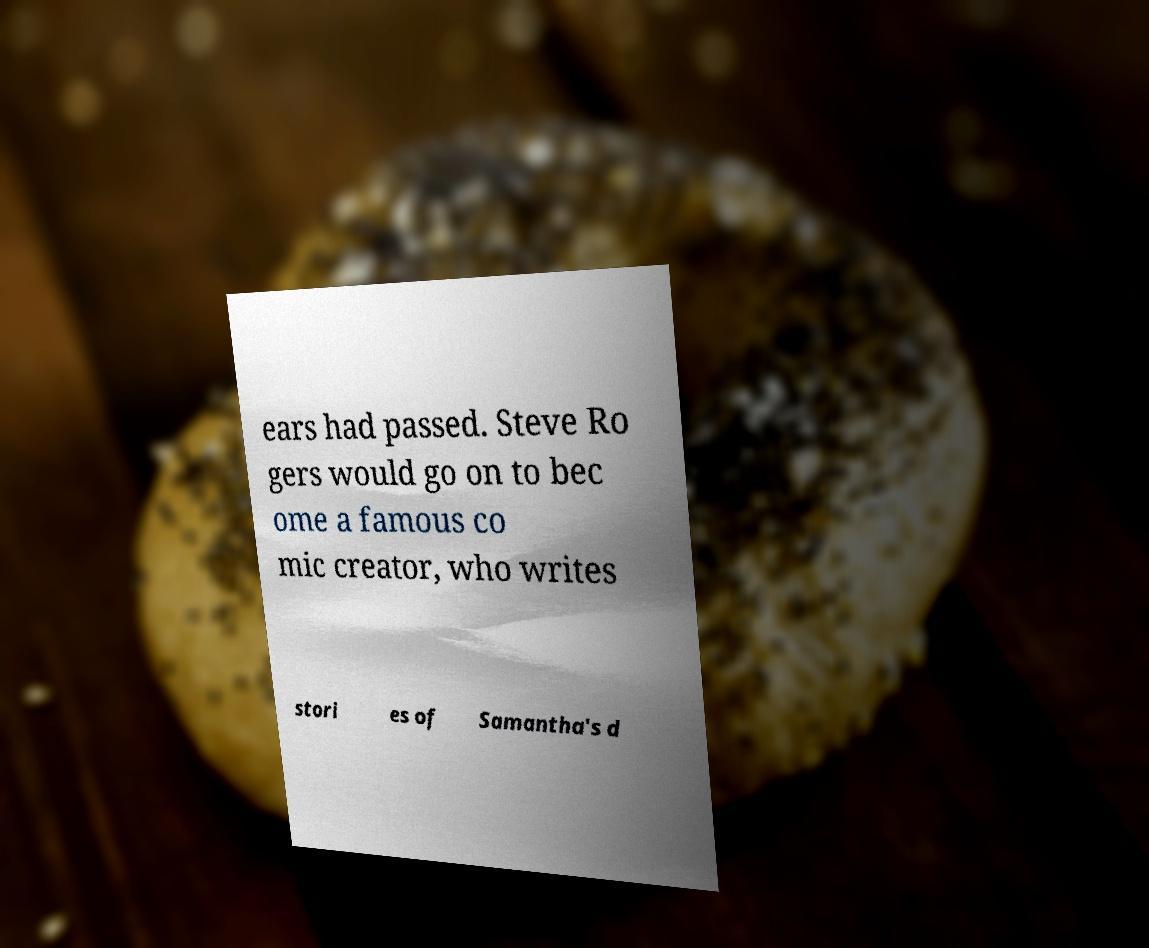There's text embedded in this image that I need extracted. Can you transcribe it verbatim? ears had passed. Steve Ro gers would go on to bec ome a famous co mic creator, who writes stori es of Samantha's d 